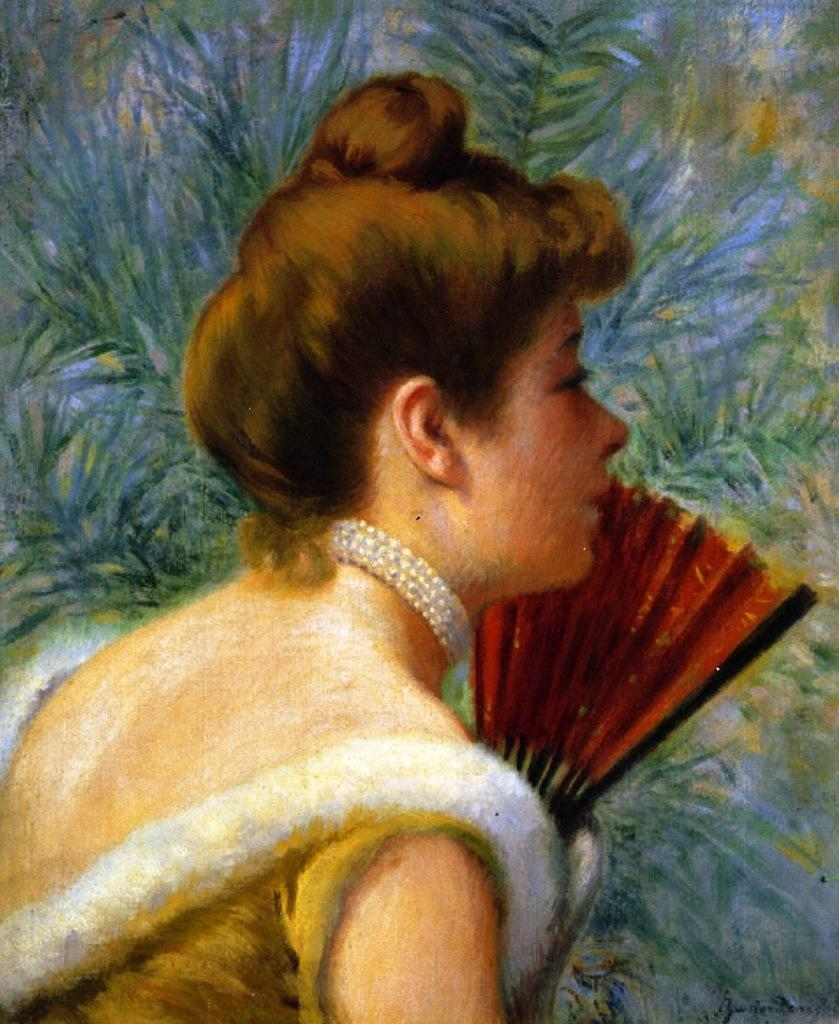What type of artwork is depicted in the image? The image is a painting. Who or what is the main subject of the painting? There is a woman in the painting. What is the woman doing in the painting? The woman is holding an object. What can be seen in the background of the painting? There appears to be a plant in the background of the painting. What is the name of the cart that the woman is riding in the painting? There is no cart present in the painting; the woman is holding an object. 